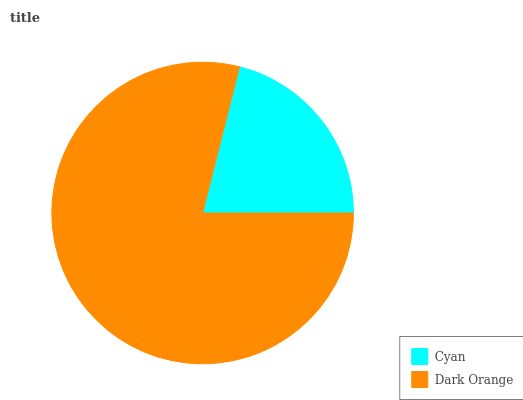Is Cyan the minimum?
Answer yes or no. Yes. Is Dark Orange the maximum?
Answer yes or no. Yes. Is Dark Orange the minimum?
Answer yes or no. No. Is Dark Orange greater than Cyan?
Answer yes or no. Yes. Is Cyan less than Dark Orange?
Answer yes or no. Yes. Is Cyan greater than Dark Orange?
Answer yes or no. No. Is Dark Orange less than Cyan?
Answer yes or no. No. Is Dark Orange the high median?
Answer yes or no. Yes. Is Cyan the low median?
Answer yes or no. Yes. Is Cyan the high median?
Answer yes or no. No. Is Dark Orange the low median?
Answer yes or no. No. 